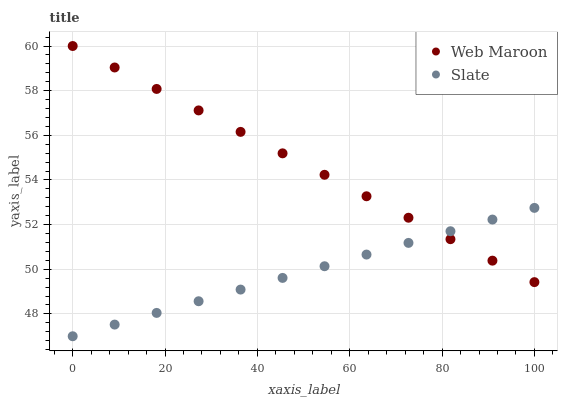Does Slate have the minimum area under the curve?
Answer yes or no. Yes. Does Web Maroon have the maximum area under the curve?
Answer yes or no. Yes. Does Web Maroon have the minimum area under the curve?
Answer yes or no. No. Is Web Maroon the smoothest?
Answer yes or no. Yes. Is Slate the roughest?
Answer yes or no. Yes. Is Web Maroon the roughest?
Answer yes or no. No. Does Slate have the lowest value?
Answer yes or no. Yes. Does Web Maroon have the lowest value?
Answer yes or no. No. Does Web Maroon have the highest value?
Answer yes or no. Yes. Does Web Maroon intersect Slate?
Answer yes or no. Yes. Is Web Maroon less than Slate?
Answer yes or no. No. Is Web Maroon greater than Slate?
Answer yes or no. No. 